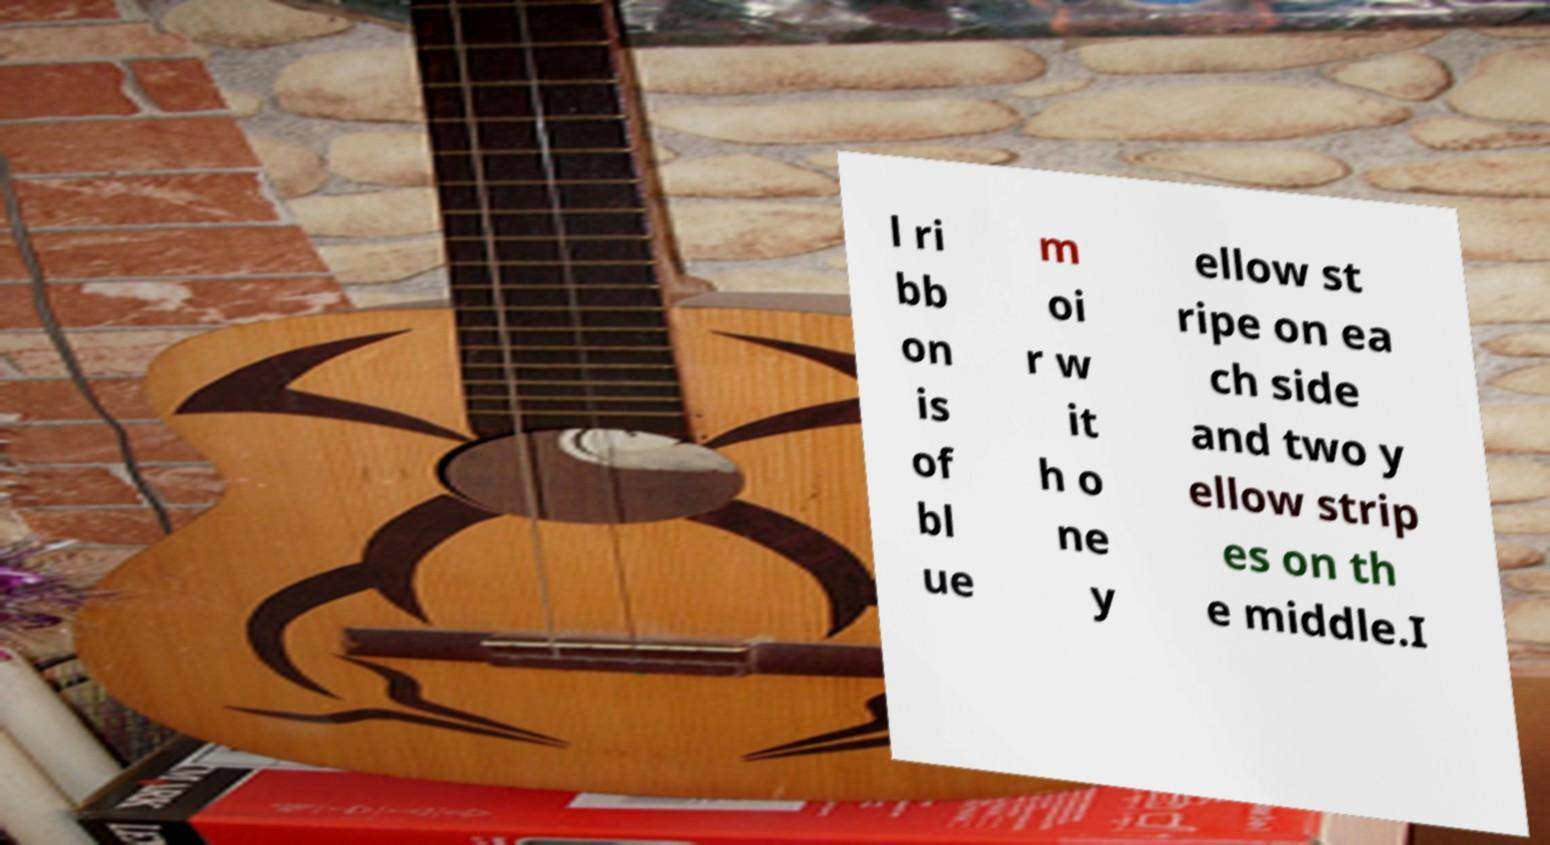There's text embedded in this image that I need extracted. Can you transcribe it verbatim? l ri bb on is of bl ue m oi r w it h o ne y ellow st ripe on ea ch side and two y ellow strip es on th e middle.I 